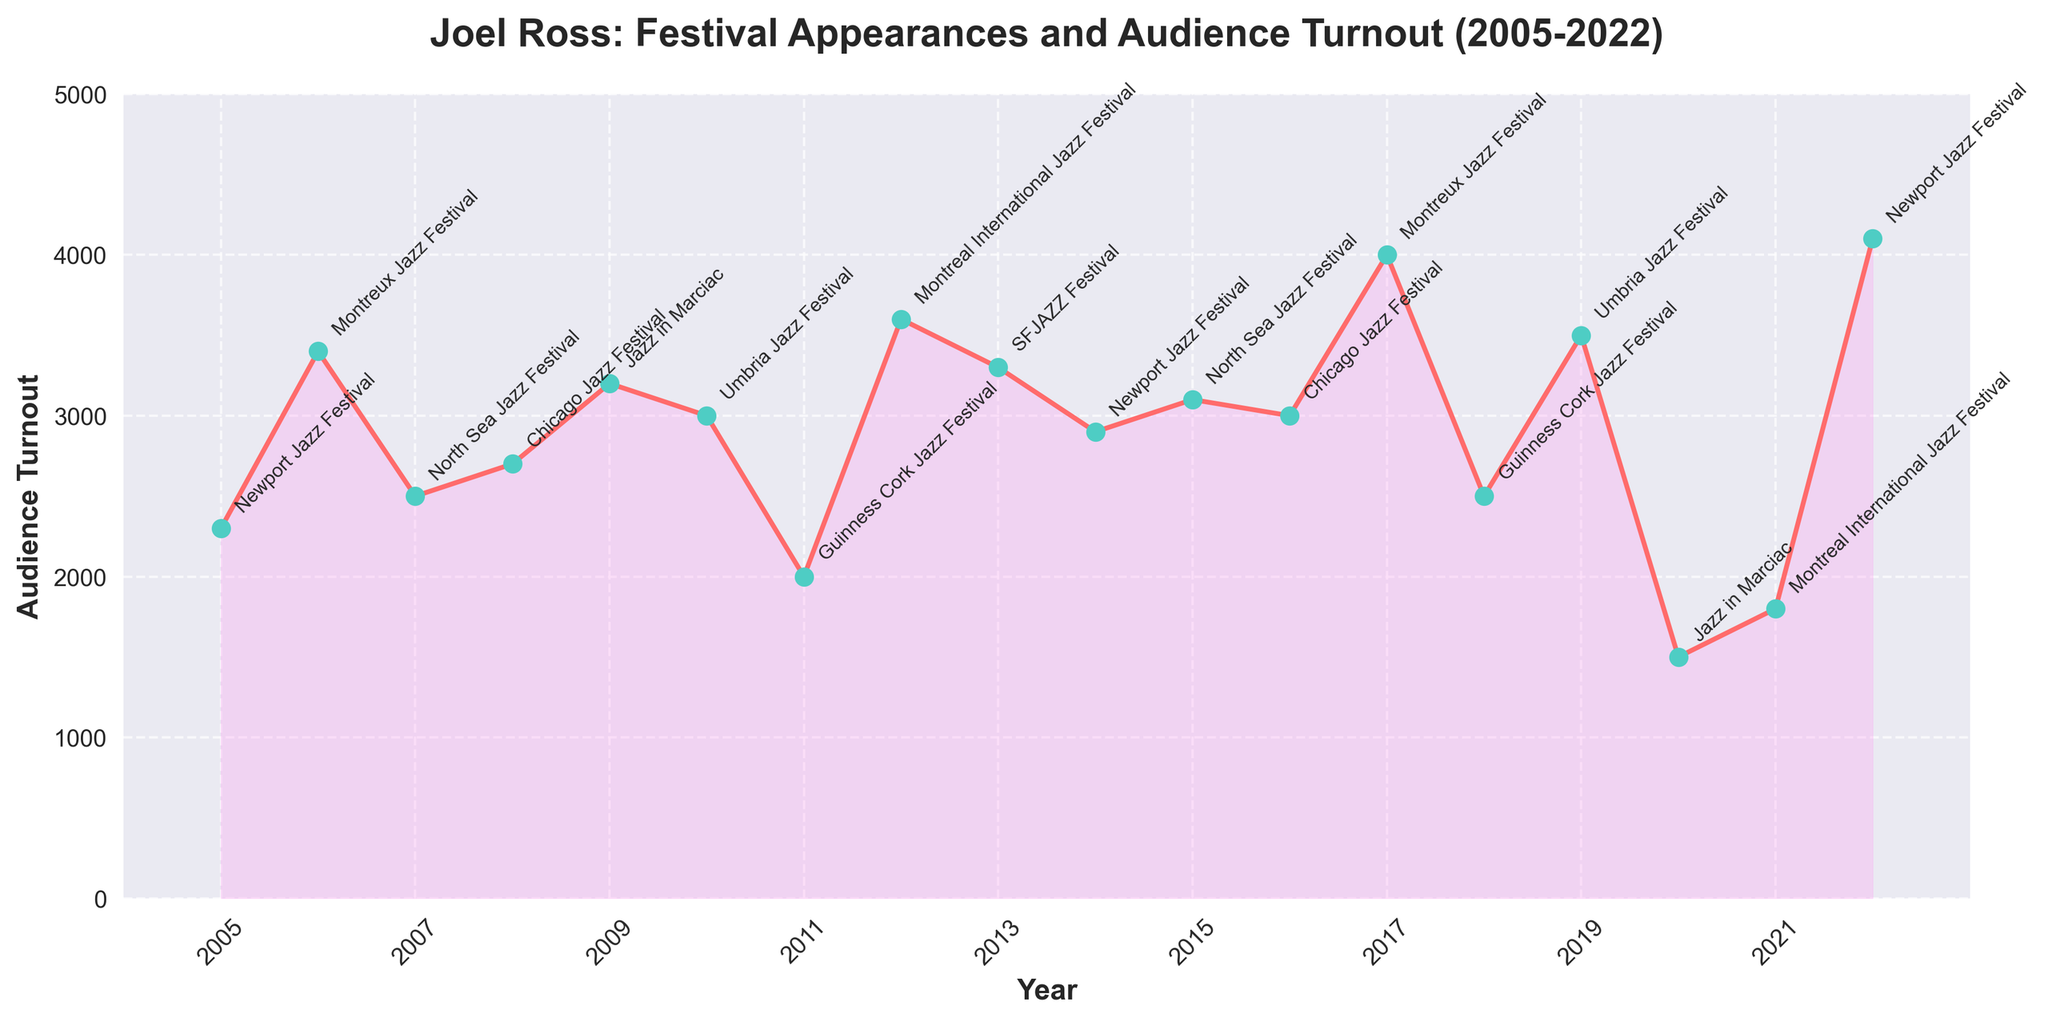what is the title of the figure? The title of the figure is prominently displayed at the top of the chart. It usually summarizes the key information presented in the plot. Here, it reads "Joel Ross: Festival Appearances and Audience Turnout (2005-2022)".
Answer: Joel Ross: Festival Appearances and Audience Turnout (2005-2022) In which year did Joel Ross have the highest audience turnout? Looking at the highest peak on the plot, we can see that it corresponds to the year 2022, with the highest audience turnout at the Newport Jazz Festival of 4100.
Answer: 2022 How many festivals did Joel Ross perform at from 2005 to 2022? Each year on the plot corresponds to a different festival, and the data ranges from 2005 to 2022. Counting the years on the x-axis shows there are 18 data points.
Answer: 18 What is the average audience turnout over the years presented? To find the average, sum up all the audience turnout values and divide by the total number of years (18). The sum is 50900, so the average is 50900 / 18.
Answer: 2827.78 How did the audience turnout in 2020 compare to 2021? In 2020, the audience turnout was 1500, and in 2021, it was 1800. Therefore, the turnout increased by 300 in 2021 compared to 2020.
Answer: The turnout increased by 300 Which festival had the lowest audience turnout, and in what year was this? The lowest point on the plot is the year 2020 with an audience turnout of 1500 at Jazz in Marciac.
Answer: Jazz in Marciac, 2020 Did Joel Ross perform at the Newport Jazz Festival more than once between 2005 and 2022? Examining the annotated festival names, we see Joel Ross performed at the Newport Jazz Festival in 2005, 2014, and 2022.
Answer: Yes In which years did Joel Ross perform at the Montreux Jazz Festival, and how did their audience turnouts compare? Joel Ross performed at the Montreux Jazz Festival in 2006 and 2017. The audience turnouts were 3400 in 2006 and 4000 in 2017, respectively.
Answer: 2006 and 2017, turnout increased by 600 Which year marked Joel Ross' first appearance at the Chicago Jazz Festival, and what was the audience turnout? Joel Ross first appeared at the Chicago Jazz Festival in 2008 with an audience turnout of 2700.
Answer: 2008, 2700 